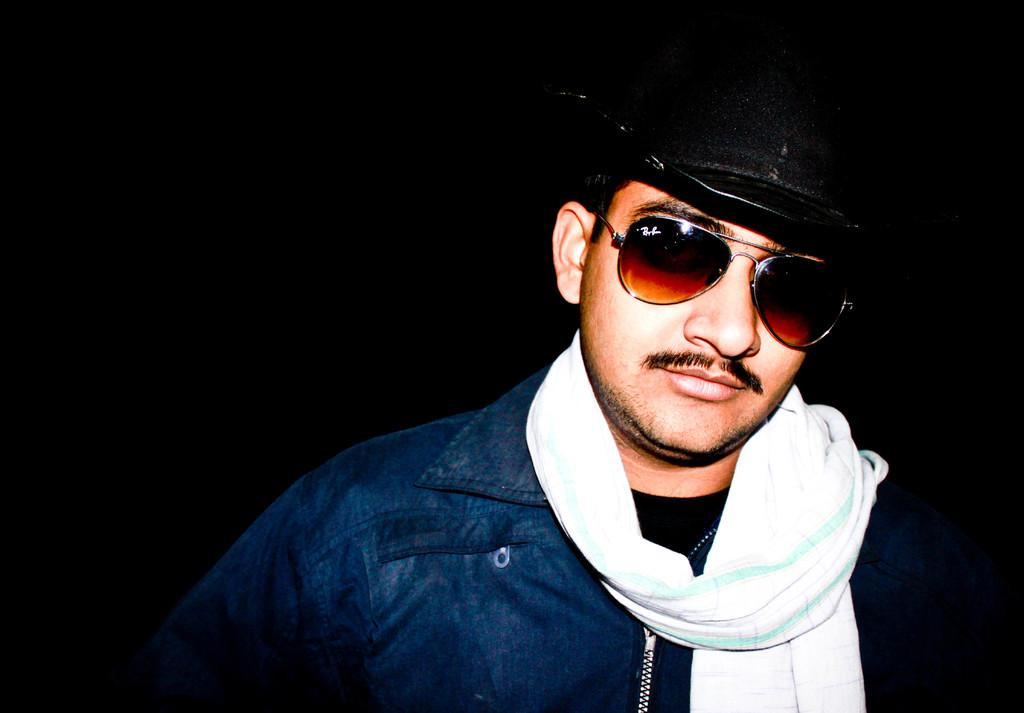What is the main subject of the image? The main subject of the image is a man. What type of jeans is the man wearing in the image? There is no information about the man's clothing, including jeans, in the provided facts. 